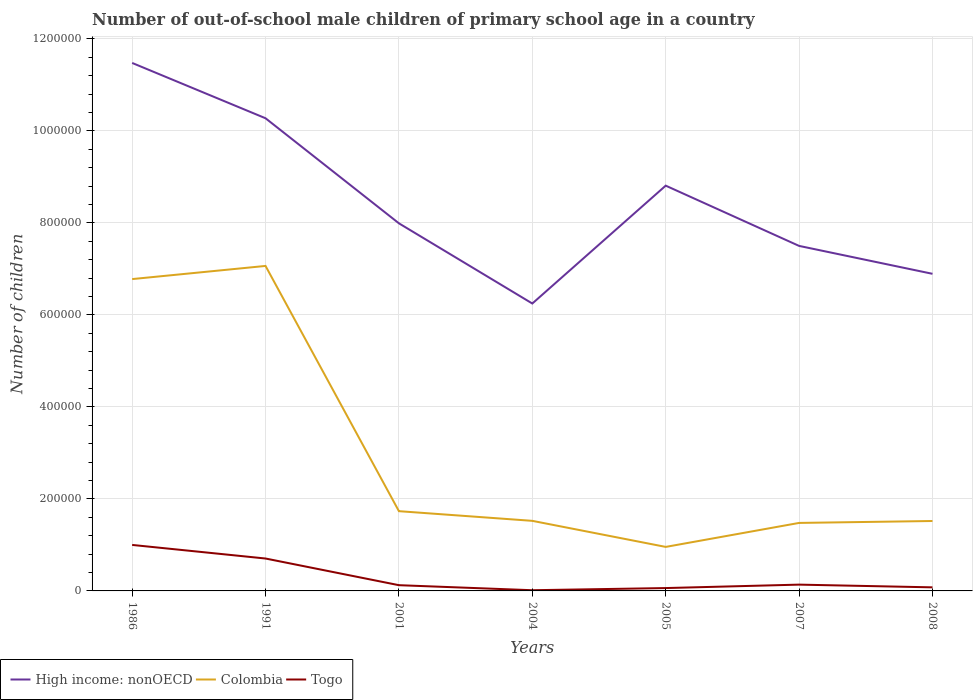Does the line corresponding to Togo intersect with the line corresponding to Colombia?
Offer a terse response. No. Is the number of lines equal to the number of legend labels?
Ensure brevity in your answer.  Yes. Across all years, what is the maximum number of out-of-school male children in High income: nonOECD?
Give a very brief answer. 6.25e+05. What is the total number of out-of-school male children in Togo in the graph?
Give a very brief answer. 6.42e+04. What is the difference between the highest and the second highest number of out-of-school male children in Colombia?
Provide a short and direct response. 6.11e+05. How many years are there in the graph?
Ensure brevity in your answer.  7. What is the difference between two consecutive major ticks on the Y-axis?
Offer a terse response. 2.00e+05. Are the values on the major ticks of Y-axis written in scientific E-notation?
Offer a very short reply. No. Does the graph contain any zero values?
Your answer should be compact. No. Does the graph contain grids?
Your response must be concise. Yes. Where does the legend appear in the graph?
Your answer should be compact. Bottom left. How are the legend labels stacked?
Provide a succinct answer. Horizontal. What is the title of the graph?
Make the answer very short. Number of out-of-school male children of primary school age in a country. What is the label or title of the X-axis?
Provide a short and direct response. Years. What is the label or title of the Y-axis?
Keep it short and to the point. Number of children. What is the Number of children of High income: nonOECD in 1986?
Ensure brevity in your answer.  1.15e+06. What is the Number of children of Colombia in 1986?
Your answer should be very brief. 6.78e+05. What is the Number of children in Togo in 1986?
Ensure brevity in your answer.  1.00e+05. What is the Number of children in High income: nonOECD in 1991?
Ensure brevity in your answer.  1.03e+06. What is the Number of children of Colombia in 1991?
Your answer should be very brief. 7.06e+05. What is the Number of children of Togo in 1991?
Your answer should be compact. 7.04e+04. What is the Number of children in High income: nonOECD in 2001?
Make the answer very short. 7.99e+05. What is the Number of children of Colombia in 2001?
Provide a short and direct response. 1.73e+05. What is the Number of children in Togo in 2001?
Ensure brevity in your answer.  1.25e+04. What is the Number of children in High income: nonOECD in 2004?
Offer a very short reply. 6.25e+05. What is the Number of children in Colombia in 2004?
Your response must be concise. 1.52e+05. What is the Number of children in Togo in 2004?
Your response must be concise. 1535. What is the Number of children in High income: nonOECD in 2005?
Offer a terse response. 8.81e+05. What is the Number of children of Colombia in 2005?
Keep it short and to the point. 9.57e+04. What is the Number of children in Togo in 2005?
Your answer should be compact. 6210. What is the Number of children in High income: nonOECD in 2007?
Give a very brief answer. 7.50e+05. What is the Number of children in Colombia in 2007?
Ensure brevity in your answer.  1.48e+05. What is the Number of children of Togo in 2007?
Offer a very short reply. 1.37e+04. What is the Number of children of High income: nonOECD in 2008?
Your response must be concise. 6.89e+05. What is the Number of children of Colombia in 2008?
Keep it short and to the point. 1.52e+05. What is the Number of children in Togo in 2008?
Offer a very short reply. 7767. Across all years, what is the maximum Number of children in High income: nonOECD?
Provide a succinct answer. 1.15e+06. Across all years, what is the maximum Number of children of Colombia?
Provide a succinct answer. 7.06e+05. Across all years, what is the maximum Number of children of Togo?
Your answer should be compact. 1.00e+05. Across all years, what is the minimum Number of children in High income: nonOECD?
Ensure brevity in your answer.  6.25e+05. Across all years, what is the minimum Number of children of Colombia?
Offer a terse response. 9.57e+04. Across all years, what is the minimum Number of children of Togo?
Your answer should be compact. 1535. What is the total Number of children in High income: nonOECD in the graph?
Ensure brevity in your answer.  5.92e+06. What is the total Number of children in Colombia in the graph?
Keep it short and to the point. 2.11e+06. What is the total Number of children of Togo in the graph?
Keep it short and to the point. 2.12e+05. What is the difference between the Number of children of High income: nonOECD in 1986 and that in 1991?
Keep it short and to the point. 1.20e+05. What is the difference between the Number of children in Colombia in 1986 and that in 1991?
Provide a succinct answer. -2.86e+04. What is the difference between the Number of children of Togo in 1986 and that in 1991?
Give a very brief answer. 2.95e+04. What is the difference between the Number of children in High income: nonOECD in 1986 and that in 2001?
Your response must be concise. 3.49e+05. What is the difference between the Number of children of Colombia in 1986 and that in 2001?
Make the answer very short. 5.04e+05. What is the difference between the Number of children in Togo in 1986 and that in 2001?
Keep it short and to the point. 8.75e+04. What is the difference between the Number of children of High income: nonOECD in 1986 and that in 2004?
Keep it short and to the point. 5.23e+05. What is the difference between the Number of children in Colombia in 1986 and that in 2004?
Provide a succinct answer. 5.26e+05. What is the difference between the Number of children in Togo in 1986 and that in 2004?
Offer a terse response. 9.84e+04. What is the difference between the Number of children in High income: nonOECD in 1986 and that in 2005?
Provide a short and direct response. 2.67e+05. What is the difference between the Number of children in Colombia in 1986 and that in 2005?
Your answer should be very brief. 5.82e+05. What is the difference between the Number of children of Togo in 1986 and that in 2005?
Your answer should be very brief. 9.38e+04. What is the difference between the Number of children of High income: nonOECD in 1986 and that in 2007?
Offer a terse response. 3.98e+05. What is the difference between the Number of children in Colombia in 1986 and that in 2007?
Your answer should be compact. 5.30e+05. What is the difference between the Number of children of Togo in 1986 and that in 2007?
Your answer should be very brief. 8.63e+04. What is the difference between the Number of children of High income: nonOECD in 1986 and that in 2008?
Give a very brief answer. 4.58e+05. What is the difference between the Number of children in Colombia in 1986 and that in 2008?
Ensure brevity in your answer.  5.26e+05. What is the difference between the Number of children in Togo in 1986 and that in 2008?
Provide a short and direct response. 9.22e+04. What is the difference between the Number of children of High income: nonOECD in 1991 and that in 2001?
Ensure brevity in your answer.  2.28e+05. What is the difference between the Number of children of Colombia in 1991 and that in 2001?
Your answer should be compact. 5.33e+05. What is the difference between the Number of children in Togo in 1991 and that in 2001?
Offer a very short reply. 5.80e+04. What is the difference between the Number of children of High income: nonOECD in 1991 and that in 2004?
Your answer should be compact. 4.03e+05. What is the difference between the Number of children in Colombia in 1991 and that in 2004?
Ensure brevity in your answer.  5.54e+05. What is the difference between the Number of children of Togo in 1991 and that in 2004?
Ensure brevity in your answer.  6.89e+04. What is the difference between the Number of children in High income: nonOECD in 1991 and that in 2005?
Give a very brief answer. 1.46e+05. What is the difference between the Number of children of Colombia in 1991 and that in 2005?
Your response must be concise. 6.11e+05. What is the difference between the Number of children in Togo in 1991 and that in 2005?
Provide a short and direct response. 6.42e+04. What is the difference between the Number of children of High income: nonOECD in 1991 and that in 2007?
Give a very brief answer. 2.77e+05. What is the difference between the Number of children in Colombia in 1991 and that in 2007?
Your answer should be very brief. 5.59e+05. What is the difference between the Number of children of Togo in 1991 and that in 2007?
Ensure brevity in your answer.  5.68e+04. What is the difference between the Number of children in High income: nonOECD in 1991 and that in 2008?
Your response must be concise. 3.38e+05. What is the difference between the Number of children of Colombia in 1991 and that in 2008?
Make the answer very short. 5.54e+05. What is the difference between the Number of children of Togo in 1991 and that in 2008?
Provide a succinct answer. 6.27e+04. What is the difference between the Number of children of High income: nonOECD in 2001 and that in 2004?
Offer a very short reply. 1.74e+05. What is the difference between the Number of children in Colombia in 2001 and that in 2004?
Your answer should be compact. 2.10e+04. What is the difference between the Number of children of Togo in 2001 and that in 2004?
Provide a succinct answer. 1.09e+04. What is the difference between the Number of children of High income: nonOECD in 2001 and that in 2005?
Make the answer very short. -8.19e+04. What is the difference between the Number of children of Colombia in 2001 and that in 2005?
Ensure brevity in your answer.  7.77e+04. What is the difference between the Number of children in Togo in 2001 and that in 2005?
Ensure brevity in your answer.  6254. What is the difference between the Number of children in High income: nonOECD in 2001 and that in 2007?
Offer a terse response. 4.91e+04. What is the difference between the Number of children in Colombia in 2001 and that in 2007?
Make the answer very short. 2.56e+04. What is the difference between the Number of children in Togo in 2001 and that in 2007?
Offer a very short reply. -1209. What is the difference between the Number of children in High income: nonOECD in 2001 and that in 2008?
Offer a very short reply. 1.10e+05. What is the difference between the Number of children of Colombia in 2001 and that in 2008?
Ensure brevity in your answer.  2.14e+04. What is the difference between the Number of children of Togo in 2001 and that in 2008?
Ensure brevity in your answer.  4697. What is the difference between the Number of children in High income: nonOECD in 2004 and that in 2005?
Ensure brevity in your answer.  -2.56e+05. What is the difference between the Number of children of Colombia in 2004 and that in 2005?
Keep it short and to the point. 5.67e+04. What is the difference between the Number of children of Togo in 2004 and that in 2005?
Your answer should be very brief. -4675. What is the difference between the Number of children in High income: nonOECD in 2004 and that in 2007?
Give a very brief answer. -1.25e+05. What is the difference between the Number of children of Colombia in 2004 and that in 2007?
Ensure brevity in your answer.  4530. What is the difference between the Number of children of Togo in 2004 and that in 2007?
Give a very brief answer. -1.21e+04. What is the difference between the Number of children in High income: nonOECD in 2004 and that in 2008?
Your response must be concise. -6.46e+04. What is the difference between the Number of children in Colombia in 2004 and that in 2008?
Your answer should be very brief. 343. What is the difference between the Number of children of Togo in 2004 and that in 2008?
Offer a very short reply. -6232. What is the difference between the Number of children in High income: nonOECD in 2005 and that in 2007?
Your response must be concise. 1.31e+05. What is the difference between the Number of children of Colombia in 2005 and that in 2007?
Your answer should be compact. -5.21e+04. What is the difference between the Number of children of Togo in 2005 and that in 2007?
Ensure brevity in your answer.  -7463. What is the difference between the Number of children of High income: nonOECD in 2005 and that in 2008?
Your answer should be compact. 1.92e+05. What is the difference between the Number of children of Colombia in 2005 and that in 2008?
Give a very brief answer. -5.63e+04. What is the difference between the Number of children of Togo in 2005 and that in 2008?
Offer a terse response. -1557. What is the difference between the Number of children in High income: nonOECD in 2007 and that in 2008?
Keep it short and to the point. 6.07e+04. What is the difference between the Number of children in Colombia in 2007 and that in 2008?
Give a very brief answer. -4187. What is the difference between the Number of children in Togo in 2007 and that in 2008?
Provide a succinct answer. 5906. What is the difference between the Number of children in High income: nonOECD in 1986 and the Number of children in Colombia in 1991?
Your answer should be very brief. 4.41e+05. What is the difference between the Number of children in High income: nonOECD in 1986 and the Number of children in Togo in 1991?
Your response must be concise. 1.08e+06. What is the difference between the Number of children in Colombia in 1986 and the Number of children in Togo in 1991?
Make the answer very short. 6.07e+05. What is the difference between the Number of children of High income: nonOECD in 1986 and the Number of children of Colombia in 2001?
Provide a short and direct response. 9.74e+05. What is the difference between the Number of children of High income: nonOECD in 1986 and the Number of children of Togo in 2001?
Provide a short and direct response. 1.14e+06. What is the difference between the Number of children of Colombia in 1986 and the Number of children of Togo in 2001?
Your response must be concise. 6.65e+05. What is the difference between the Number of children in High income: nonOECD in 1986 and the Number of children in Colombia in 2004?
Offer a terse response. 9.95e+05. What is the difference between the Number of children in High income: nonOECD in 1986 and the Number of children in Togo in 2004?
Your answer should be compact. 1.15e+06. What is the difference between the Number of children of Colombia in 1986 and the Number of children of Togo in 2004?
Make the answer very short. 6.76e+05. What is the difference between the Number of children of High income: nonOECD in 1986 and the Number of children of Colombia in 2005?
Make the answer very short. 1.05e+06. What is the difference between the Number of children of High income: nonOECD in 1986 and the Number of children of Togo in 2005?
Make the answer very short. 1.14e+06. What is the difference between the Number of children in Colombia in 1986 and the Number of children in Togo in 2005?
Your response must be concise. 6.72e+05. What is the difference between the Number of children of High income: nonOECD in 1986 and the Number of children of Colombia in 2007?
Provide a short and direct response. 1.00e+06. What is the difference between the Number of children in High income: nonOECD in 1986 and the Number of children in Togo in 2007?
Provide a short and direct response. 1.13e+06. What is the difference between the Number of children in Colombia in 1986 and the Number of children in Togo in 2007?
Make the answer very short. 6.64e+05. What is the difference between the Number of children of High income: nonOECD in 1986 and the Number of children of Colombia in 2008?
Offer a terse response. 9.96e+05. What is the difference between the Number of children of High income: nonOECD in 1986 and the Number of children of Togo in 2008?
Give a very brief answer. 1.14e+06. What is the difference between the Number of children in Colombia in 1986 and the Number of children in Togo in 2008?
Give a very brief answer. 6.70e+05. What is the difference between the Number of children of High income: nonOECD in 1991 and the Number of children of Colombia in 2001?
Your response must be concise. 8.54e+05. What is the difference between the Number of children of High income: nonOECD in 1991 and the Number of children of Togo in 2001?
Your answer should be very brief. 1.01e+06. What is the difference between the Number of children of Colombia in 1991 and the Number of children of Togo in 2001?
Give a very brief answer. 6.94e+05. What is the difference between the Number of children of High income: nonOECD in 1991 and the Number of children of Colombia in 2004?
Your response must be concise. 8.75e+05. What is the difference between the Number of children in High income: nonOECD in 1991 and the Number of children in Togo in 2004?
Offer a very short reply. 1.03e+06. What is the difference between the Number of children in Colombia in 1991 and the Number of children in Togo in 2004?
Your answer should be compact. 7.05e+05. What is the difference between the Number of children of High income: nonOECD in 1991 and the Number of children of Colombia in 2005?
Provide a short and direct response. 9.32e+05. What is the difference between the Number of children in High income: nonOECD in 1991 and the Number of children in Togo in 2005?
Your response must be concise. 1.02e+06. What is the difference between the Number of children in Colombia in 1991 and the Number of children in Togo in 2005?
Provide a short and direct response. 7.00e+05. What is the difference between the Number of children in High income: nonOECD in 1991 and the Number of children in Colombia in 2007?
Give a very brief answer. 8.80e+05. What is the difference between the Number of children of High income: nonOECD in 1991 and the Number of children of Togo in 2007?
Ensure brevity in your answer.  1.01e+06. What is the difference between the Number of children in Colombia in 1991 and the Number of children in Togo in 2007?
Provide a succinct answer. 6.93e+05. What is the difference between the Number of children of High income: nonOECD in 1991 and the Number of children of Colombia in 2008?
Provide a short and direct response. 8.75e+05. What is the difference between the Number of children of High income: nonOECD in 1991 and the Number of children of Togo in 2008?
Provide a succinct answer. 1.02e+06. What is the difference between the Number of children of Colombia in 1991 and the Number of children of Togo in 2008?
Keep it short and to the point. 6.99e+05. What is the difference between the Number of children of High income: nonOECD in 2001 and the Number of children of Colombia in 2004?
Offer a terse response. 6.47e+05. What is the difference between the Number of children of High income: nonOECD in 2001 and the Number of children of Togo in 2004?
Provide a succinct answer. 7.97e+05. What is the difference between the Number of children of Colombia in 2001 and the Number of children of Togo in 2004?
Your response must be concise. 1.72e+05. What is the difference between the Number of children in High income: nonOECD in 2001 and the Number of children in Colombia in 2005?
Your answer should be compact. 7.03e+05. What is the difference between the Number of children of High income: nonOECD in 2001 and the Number of children of Togo in 2005?
Keep it short and to the point. 7.93e+05. What is the difference between the Number of children in Colombia in 2001 and the Number of children in Togo in 2005?
Your answer should be compact. 1.67e+05. What is the difference between the Number of children of High income: nonOECD in 2001 and the Number of children of Colombia in 2007?
Your answer should be very brief. 6.51e+05. What is the difference between the Number of children of High income: nonOECD in 2001 and the Number of children of Togo in 2007?
Ensure brevity in your answer.  7.85e+05. What is the difference between the Number of children in Colombia in 2001 and the Number of children in Togo in 2007?
Keep it short and to the point. 1.60e+05. What is the difference between the Number of children in High income: nonOECD in 2001 and the Number of children in Colombia in 2008?
Give a very brief answer. 6.47e+05. What is the difference between the Number of children in High income: nonOECD in 2001 and the Number of children in Togo in 2008?
Provide a succinct answer. 7.91e+05. What is the difference between the Number of children in Colombia in 2001 and the Number of children in Togo in 2008?
Your answer should be compact. 1.66e+05. What is the difference between the Number of children of High income: nonOECD in 2004 and the Number of children of Colombia in 2005?
Your answer should be very brief. 5.29e+05. What is the difference between the Number of children in High income: nonOECD in 2004 and the Number of children in Togo in 2005?
Keep it short and to the point. 6.19e+05. What is the difference between the Number of children in Colombia in 2004 and the Number of children in Togo in 2005?
Keep it short and to the point. 1.46e+05. What is the difference between the Number of children of High income: nonOECD in 2004 and the Number of children of Colombia in 2007?
Give a very brief answer. 4.77e+05. What is the difference between the Number of children in High income: nonOECD in 2004 and the Number of children in Togo in 2007?
Keep it short and to the point. 6.11e+05. What is the difference between the Number of children of Colombia in 2004 and the Number of children of Togo in 2007?
Your response must be concise. 1.39e+05. What is the difference between the Number of children in High income: nonOECD in 2004 and the Number of children in Colombia in 2008?
Offer a terse response. 4.73e+05. What is the difference between the Number of children of High income: nonOECD in 2004 and the Number of children of Togo in 2008?
Offer a very short reply. 6.17e+05. What is the difference between the Number of children in Colombia in 2004 and the Number of children in Togo in 2008?
Your response must be concise. 1.45e+05. What is the difference between the Number of children of High income: nonOECD in 2005 and the Number of children of Colombia in 2007?
Offer a very short reply. 7.33e+05. What is the difference between the Number of children in High income: nonOECD in 2005 and the Number of children in Togo in 2007?
Provide a succinct answer. 8.67e+05. What is the difference between the Number of children in Colombia in 2005 and the Number of children in Togo in 2007?
Give a very brief answer. 8.20e+04. What is the difference between the Number of children of High income: nonOECD in 2005 and the Number of children of Colombia in 2008?
Ensure brevity in your answer.  7.29e+05. What is the difference between the Number of children of High income: nonOECD in 2005 and the Number of children of Togo in 2008?
Keep it short and to the point. 8.73e+05. What is the difference between the Number of children of Colombia in 2005 and the Number of children of Togo in 2008?
Provide a short and direct response. 8.79e+04. What is the difference between the Number of children in High income: nonOECD in 2007 and the Number of children in Colombia in 2008?
Ensure brevity in your answer.  5.98e+05. What is the difference between the Number of children of High income: nonOECD in 2007 and the Number of children of Togo in 2008?
Make the answer very short. 7.42e+05. What is the difference between the Number of children in Colombia in 2007 and the Number of children in Togo in 2008?
Make the answer very short. 1.40e+05. What is the average Number of children in High income: nonOECD per year?
Ensure brevity in your answer.  8.46e+05. What is the average Number of children of Colombia per year?
Provide a short and direct response. 3.01e+05. What is the average Number of children in Togo per year?
Offer a terse response. 3.03e+04. In the year 1986, what is the difference between the Number of children in High income: nonOECD and Number of children in Colombia?
Provide a succinct answer. 4.70e+05. In the year 1986, what is the difference between the Number of children of High income: nonOECD and Number of children of Togo?
Your answer should be compact. 1.05e+06. In the year 1986, what is the difference between the Number of children in Colombia and Number of children in Togo?
Give a very brief answer. 5.78e+05. In the year 1991, what is the difference between the Number of children in High income: nonOECD and Number of children in Colombia?
Offer a terse response. 3.21e+05. In the year 1991, what is the difference between the Number of children of High income: nonOECD and Number of children of Togo?
Ensure brevity in your answer.  9.57e+05. In the year 1991, what is the difference between the Number of children of Colombia and Number of children of Togo?
Your answer should be compact. 6.36e+05. In the year 2001, what is the difference between the Number of children of High income: nonOECD and Number of children of Colombia?
Give a very brief answer. 6.26e+05. In the year 2001, what is the difference between the Number of children in High income: nonOECD and Number of children in Togo?
Provide a succinct answer. 7.87e+05. In the year 2001, what is the difference between the Number of children of Colombia and Number of children of Togo?
Offer a terse response. 1.61e+05. In the year 2004, what is the difference between the Number of children of High income: nonOECD and Number of children of Colombia?
Offer a terse response. 4.72e+05. In the year 2004, what is the difference between the Number of children in High income: nonOECD and Number of children in Togo?
Provide a short and direct response. 6.23e+05. In the year 2004, what is the difference between the Number of children of Colombia and Number of children of Togo?
Offer a terse response. 1.51e+05. In the year 2005, what is the difference between the Number of children of High income: nonOECD and Number of children of Colombia?
Give a very brief answer. 7.85e+05. In the year 2005, what is the difference between the Number of children in High income: nonOECD and Number of children in Togo?
Offer a very short reply. 8.75e+05. In the year 2005, what is the difference between the Number of children of Colombia and Number of children of Togo?
Provide a short and direct response. 8.95e+04. In the year 2007, what is the difference between the Number of children in High income: nonOECD and Number of children in Colombia?
Your answer should be very brief. 6.02e+05. In the year 2007, what is the difference between the Number of children of High income: nonOECD and Number of children of Togo?
Give a very brief answer. 7.36e+05. In the year 2007, what is the difference between the Number of children of Colombia and Number of children of Togo?
Keep it short and to the point. 1.34e+05. In the year 2008, what is the difference between the Number of children of High income: nonOECD and Number of children of Colombia?
Give a very brief answer. 5.37e+05. In the year 2008, what is the difference between the Number of children of High income: nonOECD and Number of children of Togo?
Provide a succinct answer. 6.82e+05. In the year 2008, what is the difference between the Number of children of Colombia and Number of children of Togo?
Your answer should be very brief. 1.44e+05. What is the ratio of the Number of children of High income: nonOECD in 1986 to that in 1991?
Provide a succinct answer. 1.12. What is the ratio of the Number of children in Colombia in 1986 to that in 1991?
Offer a very short reply. 0.96. What is the ratio of the Number of children of Togo in 1986 to that in 1991?
Ensure brevity in your answer.  1.42. What is the ratio of the Number of children in High income: nonOECD in 1986 to that in 2001?
Your answer should be very brief. 1.44. What is the ratio of the Number of children of Colombia in 1986 to that in 2001?
Give a very brief answer. 3.91. What is the ratio of the Number of children in Togo in 1986 to that in 2001?
Provide a short and direct response. 8.02. What is the ratio of the Number of children in High income: nonOECD in 1986 to that in 2004?
Provide a short and direct response. 1.84. What is the ratio of the Number of children in Colombia in 1986 to that in 2004?
Give a very brief answer. 4.45. What is the ratio of the Number of children in Togo in 1986 to that in 2004?
Offer a terse response. 65.12. What is the ratio of the Number of children of High income: nonOECD in 1986 to that in 2005?
Give a very brief answer. 1.3. What is the ratio of the Number of children of Colombia in 1986 to that in 2005?
Provide a succinct answer. 7.08. What is the ratio of the Number of children in Togo in 1986 to that in 2005?
Ensure brevity in your answer.  16.1. What is the ratio of the Number of children in High income: nonOECD in 1986 to that in 2007?
Provide a succinct answer. 1.53. What is the ratio of the Number of children in Colombia in 1986 to that in 2007?
Provide a succinct answer. 4.59. What is the ratio of the Number of children in Togo in 1986 to that in 2007?
Ensure brevity in your answer.  7.31. What is the ratio of the Number of children of High income: nonOECD in 1986 to that in 2008?
Your answer should be compact. 1.67. What is the ratio of the Number of children in Colombia in 1986 to that in 2008?
Ensure brevity in your answer.  4.46. What is the ratio of the Number of children in Togo in 1986 to that in 2008?
Ensure brevity in your answer.  12.87. What is the ratio of the Number of children in High income: nonOECD in 1991 to that in 2001?
Provide a short and direct response. 1.29. What is the ratio of the Number of children in Colombia in 1991 to that in 2001?
Your answer should be compact. 4.08. What is the ratio of the Number of children in Togo in 1991 to that in 2001?
Make the answer very short. 5.65. What is the ratio of the Number of children in High income: nonOECD in 1991 to that in 2004?
Ensure brevity in your answer.  1.64. What is the ratio of the Number of children of Colombia in 1991 to that in 2004?
Your response must be concise. 4.64. What is the ratio of the Number of children of Togo in 1991 to that in 2004?
Your answer should be compact. 45.89. What is the ratio of the Number of children of High income: nonOECD in 1991 to that in 2005?
Offer a very short reply. 1.17. What is the ratio of the Number of children of Colombia in 1991 to that in 2005?
Offer a very short reply. 7.38. What is the ratio of the Number of children of Togo in 1991 to that in 2005?
Your answer should be compact. 11.34. What is the ratio of the Number of children of High income: nonOECD in 1991 to that in 2007?
Ensure brevity in your answer.  1.37. What is the ratio of the Number of children of Colombia in 1991 to that in 2007?
Offer a terse response. 4.78. What is the ratio of the Number of children of Togo in 1991 to that in 2007?
Provide a succinct answer. 5.15. What is the ratio of the Number of children in High income: nonOECD in 1991 to that in 2008?
Your answer should be very brief. 1.49. What is the ratio of the Number of children in Colombia in 1991 to that in 2008?
Your response must be concise. 4.65. What is the ratio of the Number of children in Togo in 1991 to that in 2008?
Give a very brief answer. 9.07. What is the ratio of the Number of children in High income: nonOECD in 2001 to that in 2004?
Offer a very short reply. 1.28. What is the ratio of the Number of children in Colombia in 2001 to that in 2004?
Ensure brevity in your answer.  1.14. What is the ratio of the Number of children in Togo in 2001 to that in 2004?
Provide a short and direct response. 8.12. What is the ratio of the Number of children in High income: nonOECD in 2001 to that in 2005?
Provide a short and direct response. 0.91. What is the ratio of the Number of children of Colombia in 2001 to that in 2005?
Your response must be concise. 1.81. What is the ratio of the Number of children in Togo in 2001 to that in 2005?
Your answer should be very brief. 2.01. What is the ratio of the Number of children in High income: nonOECD in 2001 to that in 2007?
Provide a short and direct response. 1.07. What is the ratio of the Number of children of Colombia in 2001 to that in 2007?
Give a very brief answer. 1.17. What is the ratio of the Number of children of Togo in 2001 to that in 2007?
Your answer should be very brief. 0.91. What is the ratio of the Number of children in High income: nonOECD in 2001 to that in 2008?
Offer a very short reply. 1.16. What is the ratio of the Number of children of Colombia in 2001 to that in 2008?
Keep it short and to the point. 1.14. What is the ratio of the Number of children of Togo in 2001 to that in 2008?
Provide a short and direct response. 1.6. What is the ratio of the Number of children of High income: nonOECD in 2004 to that in 2005?
Your answer should be very brief. 0.71. What is the ratio of the Number of children of Colombia in 2004 to that in 2005?
Give a very brief answer. 1.59. What is the ratio of the Number of children in Togo in 2004 to that in 2005?
Keep it short and to the point. 0.25. What is the ratio of the Number of children in High income: nonOECD in 2004 to that in 2007?
Give a very brief answer. 0.83. What is the ratio of the Number of children in Colombia in 2004 to that in 2007?
Keep it short and to the point. 1.03. What is the ratio of the Number of children of Togo in 2004 to that in 2007?
Keep it short and to the point. 0.11. What is the ratio of the Number of children in High income: nonOECD in 2004 to that in 2008?
Your answer should be compact. 0.91. What is the ratio of the Number of children in Colombia in 2004 to that in 2008?
Your answer should be compact. 1. What is the ratio of the Number of children of Togo in 2004 to that in 2008?
Ensure brevity in your answer.  0.2. What is the ratio of the Number of children in High income: nonOECD in 2005 to that in 2007?
Your response must be concise. 1.17. What is the ratio of the Number of children in Colombia in 2005 to that in 2007?
Your response must be concise. 0.65. What is the ratio of the Number of children of Togo in 2005 to that in 2007?
Your response must be concise. 0.45. What is the ratio of the Number of children of High income: nonOECD in 2005 to that in 2008?
Offer a very short reply. 1.28. What is the ratio of the Number of children in Colombia in 2005 to that in 2008?
Your answer should be compact. 0.63. What is the ratio of the Number of children of Togo in 2005 to that in 2008?
Provide a short and direct response. 0.8. What is the ratio of the Number of children in High income: nonOECD in 2007 to that in 2008?
Your answer should be compact. 1.09. What is the ratio of the Number of children of Colombia in 2007 to that in 2008?
Keep it short and to the point. 0.97. What is the ratio of the Number of children in Togo in 2007 to that in 2008?
Keep it short and to the point. 1.76. What is the difference between the highest and the second highest Number of children of High income: nonOECD?
Your answer should be compact. 1.20e+05. What is the difference between the highest and the second highest Number of children of Colombia?
Offer a very short reply. 2.86e+04. What is the difference between the highest and the second highest Number of children in Togo?
Offer a terse response. 2.95e+04. What is the difference between the highest and the lowest Number of children of High income: nonOECD?
Provide a succinct answer. 5.23e+05. What is the difference between the highest and the lowest Number of children of Colombia?
Give a very brief answer. 6.11e+05. What is the difference between the highest and the lowest Number of children in Togo?
Keep it short and to the point. 9.84e+04. 